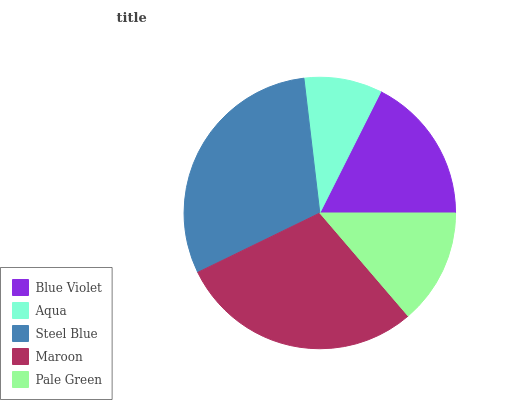Is Aqua the minimum?
Answer yes or no. Yes. Is Steel Blue the maximum?
Answer yes or no. Yes. Is Steel Blue the minimum?
Answer yes or no. No. Is Aqua the maximum?
Answer yes or no. No. Is Steel Blue greater than Aqua?
Answer yes or no. Yes. Is Aqua less than Steel Blue?
Answer yes or no. Yes. Is Aqua greater than Steel Blue?
Answer yes or no. No. Is Steel Blue less than Aqua?
Answer yes or no. No. Is Blue Violet the high median?
Answer yes or no. Yes. Is Blue Violet the low median?
Answer yes or no. Yes. Is Pale Green the high median?
Answer yes or no. No. Is Aqua the low median?
Answer yes or no. No. 